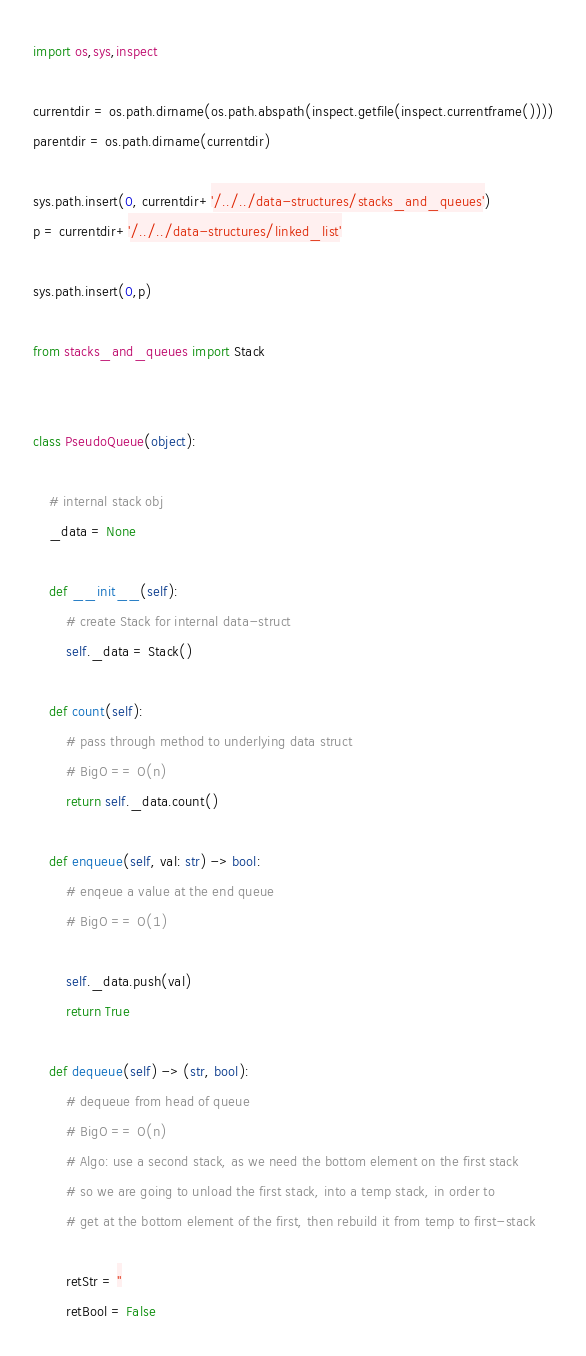<code> <loc_0><loc_0><loc_500><loc_500><_Python_>import os,sys,inspect

currentdir = os.path.dirname(os.path.abspath(inspect.getfile(inspect.currentframe())))
parentdir = os.path.dirname(currentdir)

sys.path.insert(0, currentdir+'/../../data-structures/stacks_and_queues')
p = currentdir+'/../../data-structures/linked_list'

sys.path.insert(0,p)

from stacks_and_queues import Stack


class PseudoQueue(object):

    # internal stack obj
    _data = None

    def __init__(self):
        # create Stack for internal data-struct
        self._data = Stack()

    def count(self):
        # pass through method to underlying data struct
        # BigO == O(n)
        return self._data.count()

    def enqueue(self, val: str) -> bool:
        # enqeue a value at the end queue
        # BigO == O(1)

        self._data.push(val)
        return True

    def dequeue(self) -> (str, bool):
        # dequeue from head of queue
        # BigO == O(n)
        # Algo: use a second stack, as we need the bottom element on the first stack
        # so we are going to unload the first stack, into a temp stack, in order to
        # get at the bottom element of the first, then rebuild it from temp to first-stack

        retStr = ''
        retBool = False
</code> 